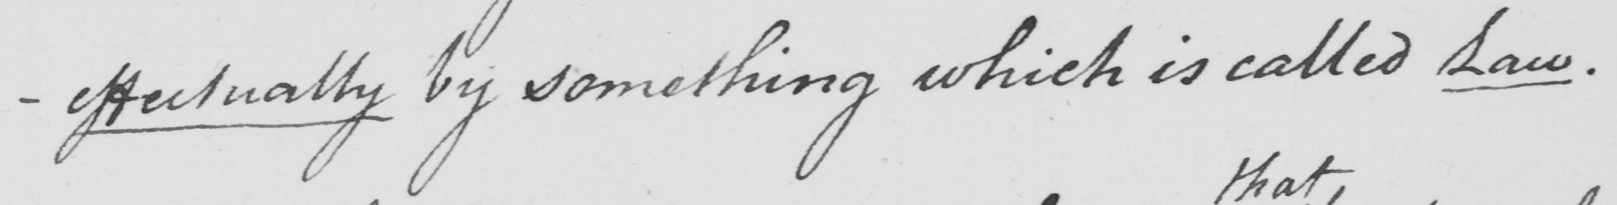Please transcribe the handwritten text in this image. -effectually by something which is called Law . 